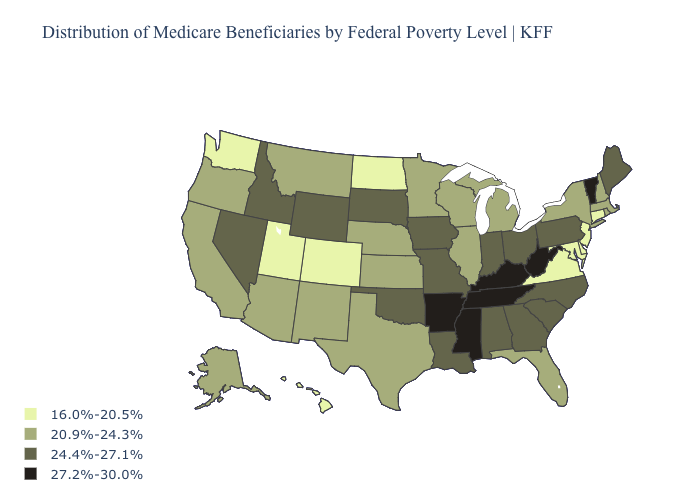What is the lowest value in states that border Utah?
Short answer required. 16.0%-20.5%. Name the states that have a value in the range 20.9%-24.3%?
Concise answer only. Alaska, Arizona, California, Florida, Illinois, Kansas, Massachusetts, Michigan, Minnesota, Montana, Nebraska, New Hampshire, New Mexico, New York, Oregon, Rhode Island, Texas, Wisconsin. Which states have the lowest value in the USA?
Quick response, please. Colorado, Connecticut, Delaware, Hawaii, Maryland, New Jersey, North Dakota, Utah, Virginia, Washington. What is the highest value in the Northeast ?
Answer briefly. 27.2%-30.0%. Is the legend a continuous bar?
Write a very short answer. No. Does West Virginia have a lower value than North Dakota?
Quick response, please. No. What is the value of Hawaii?
Write a very short answer. 16.0%-20.5%. Which states have the lowest value in the Northeast?
Be succinct. Connecticut, New Jersey. What is the value of New Hampshire?
Short answer required. 20.9%-24.3%. Does Alaska have the lowest value in the USA?
Be succinct. No. Does West Virginia have the highest value in the USA?
Give a very brief answer. Yes. Does the map have missing data?
Short answer required. No. What is the value of North Carolina?
Short answer required. 24.4%-27.1%. Does Texas have a lower value than Tennessee?
Keep it brief. Yes. Name the states that have a value in the range 20.9%-24.3%?
Quick response, please. Alaska, Arizona, California, Florida, Illinois, Kansas, Massachusetts, Michigan, Minnesota, Montana, Nebraska, New Hampshire, New Mexico, New York, Oregon, Rhode Island, Texas, Wisconsin. 